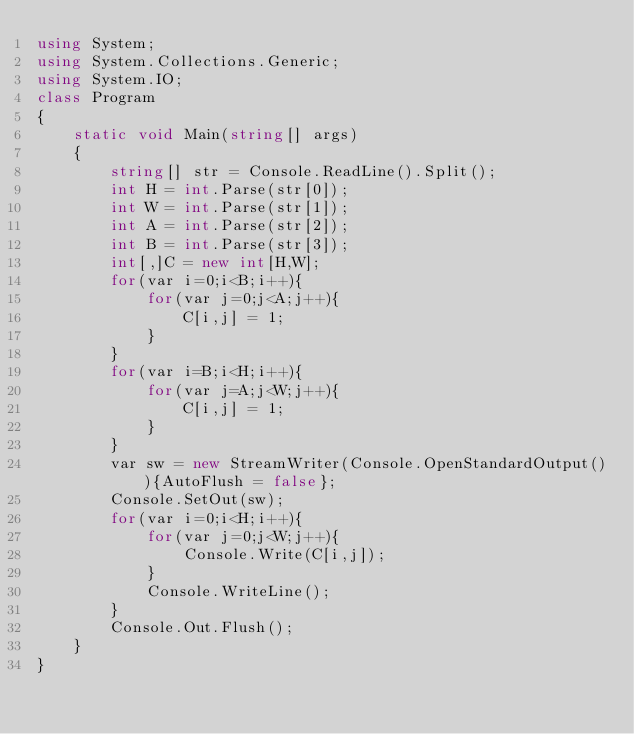Convert code to text. <code><loc_0><loc_0><loc_500><loc_500><_C#_>using System;
using System.Collections.Generic;
using System.IO;
class Program
{
	static void Main(string[] args)
	{
		string[] str = Console.ReadLine().Split();
		int H = int.Parse(str[0]);
		int W = int.Parse(str[1]);
		int A = int.Parse(str[2]);
		int B = int.Parse(str[3]);
		int[,]C = new int[H,W];
		for(var i=0;i<B;i++){
			for(var j=0;j<A;j++){
				C[i,j] = 1;
			}
		}
		for(var i=B;i<H;i++){
			for(var j=A;j<W;j++){
				C[i,j] = 1;
			}
		}
      	var sw = new StreamWriter(Console.OpenStandardOutput()){AutoFlush = false};
		Console.SetOut(sw);
		for(var i=0;i<H;i++){
			for(var j=0;j<W;j++){
				Console.Write(C[i,j]);
			}
			Console.WriteLine();
		}
	    Console.Out.Flush();
	}
}</code> 